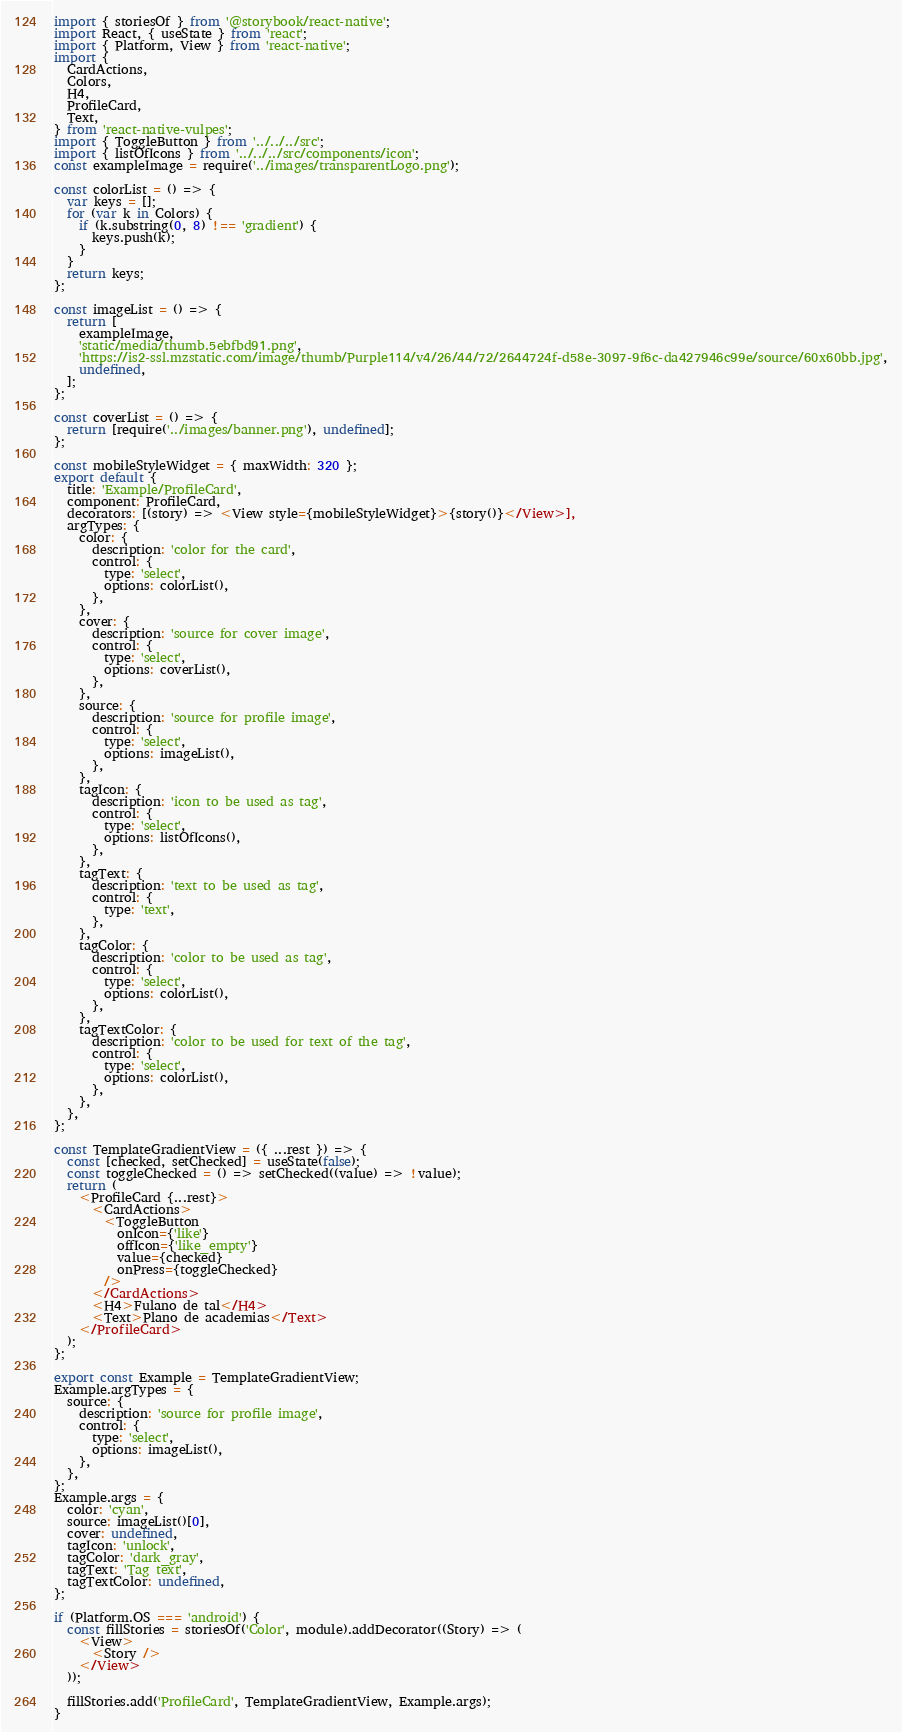<code> <loc_0><loc_0><loc_500><loc_500><_JavaScript_>import { storiesOf } from '@storybook/react-native';
import React, { useState } from 'react';
import { Platform, View } from 'react-native';
import {
  CardActions,
  Colors,
  H4,
  ProfileCard,
  Text,
} from 'react-native-vulpes';
import { ToggleButton } from '../../../src';
import { listOfIcons } from '../../../src/components/icon';
const exampleImage = require('../images/transparentLogo.png');

const colorList = () => {
  var keys = [];
  for (var k in Colors) {
    if (k.substring(0, 8) !== 'gradient') {
      keys.push(k);
    }
  }
  return keys;
};

const imageList = () => {
  return [
    exampleImage,
    'static/media/thumb.5ebfbd91.png',
    'https://is2-ssl.mzstatic.com/image/thumb/Purple114/v4/26/44/72/2644724f-d58e-3097-9f6c-da427946c99e/source/60x60bb.jpg',
    undefined,
  ];
};

const coverList = () => {
  return [require('../images/banner.png'), undefined];
};

const mobileStyleWidget = { maxWidth: 320 };
export default {
  title: 'Example/ProfileCard',
  component: ProfileCard,
  decorators: [(story) => <View style={mobileStyleWidget}>{story()}</View>],
  argTypes: {
    color: {
      description: 'color for the card',
      control: {
        type: 'select',
        options: colorList(),
      },
    },
    cover: {
      description: 'source for cover image',
      control: {
        type: 'select',
        options: coverList(),
      },
    },
    source: {
      description: 'source for profile image',
      control: {
        type: 'select',
        options: imageList(),
      },
    },
    tagIcon: {
      description: 'icon to be used as tag',
      control: {
        type: 'select',
        options: listOfIcons(),
      },
    },
    tagText: {
      description: 'text to be used as tag',
      control: {
        type: 'text',
      },
    },
    tagColor: {
      description: 'color to be used as tag',
      control: {
        type: 'select',
        options: colorList(),
      },
    },
    tagTextColor: {
      description: 'color to be used for text of the tag',
      control: {
        type: 'select',
        options: colorList(),
      },
    },
  },
};

const TemplateGradientView = ({ ...rest }) => {
  const [checked, setChecked] = useState(false);
  const toggleChecked = () => setChecked((value) => !value);
  return (
    <ProfileCard {...rest}>
      <CardActions>
        <ToggleButton
          onIcon={'like'}
          offIcon={'like_empty'}
          value={checked}
          onPress={toggleChecked}
        />
      </CardActions>
      <H4>Fulano de tal</H4>
      <Text>Plano de academias</Text>
    </ProfileCard>
  );
};

export const Example = TemplateGradientView;
Example.argTypes = {
  source: {
    description: 'source for profile image',
    control: {
      type: 'select',
      options: imageList(),
    },
  },
};
Example.args = {
  color: 'cyan',
  source: imageList()[0],
  cover: undefined,
  tagIcon: 'unlock',
  tagColor: 'dark_gray',
  tagText: 'Tag text',
  tagTextColor: undefined,
};

if (Platform.OS === 'android') {
  const fillStories = storiesOf('Color', module).addDecorator((Story) => (
    <View>
      <Story />
    </View>
  ));

  fillStories.add('ProfileCard', TemplateGradientView, Example.args);
}
</code> 